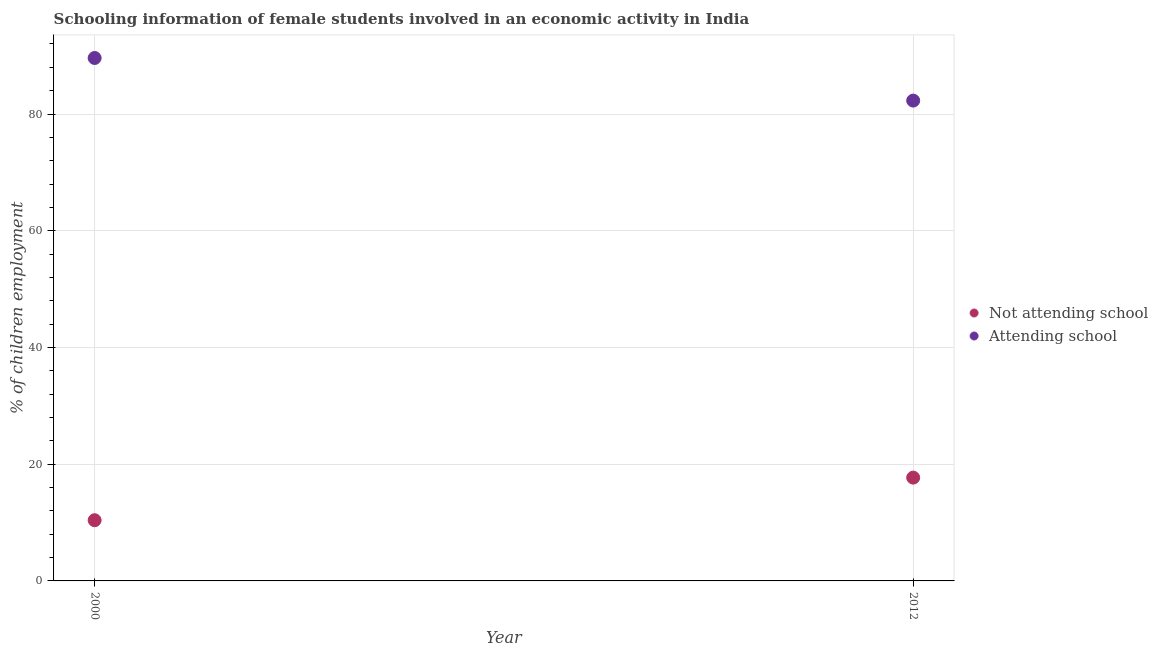How many different coloured dotlines are there?
Provide a short and direct response. 2. Is the number of dotlines equal to the number of legend labels?
Your answer should be very brief. Yes. What is the percentage of employed females who are attending school in 2012?
Your answer should be very brief. 82.3. Across all years, what is the minimum percentage of employed females who are attending school?
Provide a short and direct response. 82.3. What is the total percentage of employed females who are attending school in the graph?
Keep it short and to the point. 171.9. What is the difference between the percentage of employed females who are attending school in 2000 and that in 2012?
Offer a very short reply. 7.3. What is the difference between the percentage of employed females who are attending school in 2012 and the percentage of employed females who are not attending school in 2000?
Offer a very short reply. 71.9. What is the average percentage of employed females who are attending school per year?
Offer a very short reply. 85.95. In the year 2012, what is the difference between the percentage of employed females who are not attending school and percentage of employed females who are attending school?
Your response must be concise. -64.6. What is the ratio of the percentage of employed females who are attending school in 2000 to that in 2012?
Offer a terse response. 1.09. Does the percentage of employed females who are not attending school monotonically increase over the years?
Ensure brevity in your answer.  Yes. Is the percentage of employed females who are attending school strictly greater than the percentage of employed females who are not attending school over the years?
Make the answer very short. Yes. How many years are there in the graph?
Your answer should be compact. 2. Are the values on the major ticks of Y-axis written in scientific E-notation?
Offer a terse response. No. Does the graph contain any zero values?
Your answer should be compact. No. Does the graph contain grids?
Give a very brief answer. Yes. Where does the legend appear in the graph?
Your response must be concise. Center right. What is the title of the graph?
Provide a succinct answer. Schooling information of female students involved in an economic activity in India. What is the label or title of the X-axis?
Keep it short and to the point. Year. What is the label or title of the Y-axis?
Offer a terse response. % of children employment. What is the % of children employment in Attending school in 2000?
Make the answer very short. 89.6. What is the % of children employment of Attending school in 2012?
Offer a very short reply. 82.3. Across all years, what is the maximum % of children employment in Attending school?
Your answer should be compact. 89.6. Across all years, what is the minimum % of children employment of Not attending school?
Your response must be concise. 10.4. Across all years, what is the minimum % of children employment in Attending school?
Make the answer very short. 82.3. What is the total % of children employment in Not attending school in the graph?
Your answer should be very brief. 28.1. What is the total % of children employment in Attending school in the graph?
Your answer should be compact. 171.9. What is the difference between the % of children employment of Attending school in 2000 and that in 2012?
Ensure brevity in your answer.  7.3. What is the difference between the % of children employment of Not attending school in 2000 and the % of children employment of Attending school in 2012?
Your answer should be very brief. -71.9. What is the average % of children employment in Not attending school per year?
Offer a terse response. 14.05. What is the average % of children employment of Attending school per year?
Give a very brief answer. 85.95. In the year 2000, what is the difference between the % of children employment in Not attending school and % of children employment in Attending school?
Your response must be concise. -79.2. In the year 2012, what is the difference between the % of children employment in Not attending school and % of children employment in Attending school?
Ensure brevity in your answer.  -64.6. What is the ratio of the % of children employment in Not attending school in 2000 to that in 2012?
Offer a very short reply. 0.59. What is the ratio of the % of children employment of Attending school in 2000 to that in 2012?
Give a very brief answer. 1.09. What is the difference between the highest and the second highest % of children employment in Attending school?
Your answer should be compact. 7.3. What is the difference between the highest and the lowest % of children employment of Attending school?
Provide a succinct answer. 7.3. 